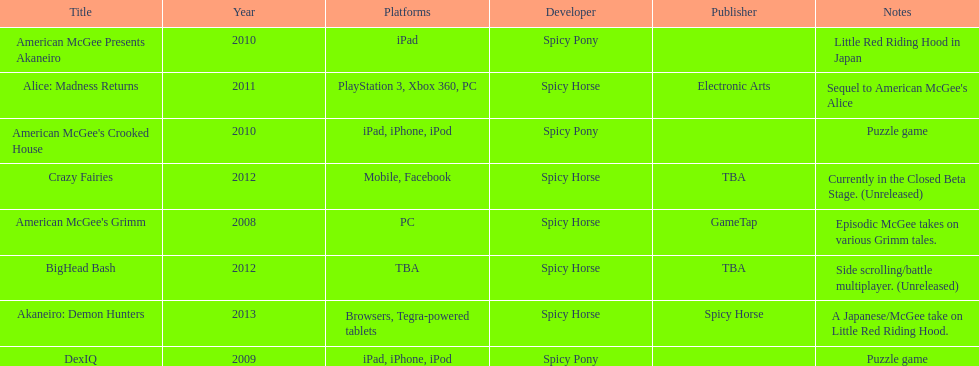What are all the titles of games published? American McGee's Grimm, DexIQ, American McGee Presents Akaneiro, American McGee's Crooked House, Alice: Madness Returns, BigHead Bash, Crazy Fairies, Akaneiro: Demon Hunters. What are all the names of the publishers? GameTap, , , , Electronic Arts, TBA, TBA, Spicy Horse. What is the published game title that corresponds to electronic arts? Alice: Madness Returns. 